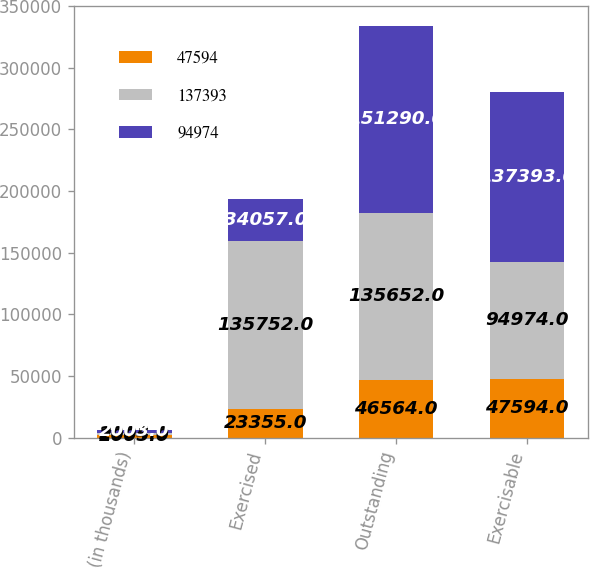Convert chart to OTSL. <chart><loc_0><loc_0><loc_500><loc_500><stacked_bar_chart><ecel><fcel>(in thousands)<fcel>Exercised<fcel>Outstanding<fcel>Exercisable<nl><fcel>47594<fcel>2005<fcel>23355<fcel>46564<fcel>47594<nl><fcel>137393<fcel>2004<fcel>135752<fcel>135652<fcel>94974<nl><fcel>94974<fcel>2003<fcel>34057<fcel>151290<fcel>137393<nl></chart> 